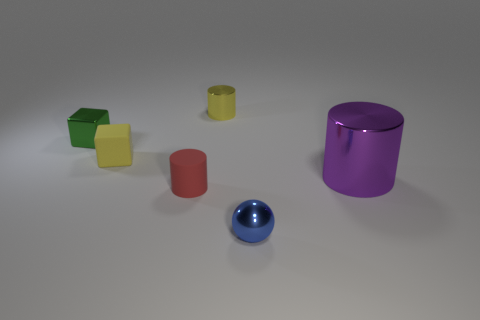What number of other things are there of the same material as the yellow cylinder
Offer a very short reply. 3. What size is the metal cylinder that is in front of the small green metal object?
Offer a very short reply. Large. There is a tiny matte thing in front of the large purple shiny thing; what number of tiny blue metallic spheres are behind it?
Offer a terse response. 0. There is a matte thing that is in front of the purple object; does it have the same shape as the shiny thing that is behind the tiny green metal object?
Your response must be concise. Yes. What number of cylinders are to the left of the large metallic thing and in front of the small green metal thing?
Offer a very short reply. 1. Is there a tiny cylinder that has the same color as the rubber block?
Make the answer very short. Yes. There is a blue object that is the same size as the yellow matte cube; what is its shape?
Your answer should be very brief. Sphere. There is a tiny metal cylinder; are there any purple metal cylinders on the right side of it?
Offer a very short reply. Yes. Is the thing right of the small shiny ball made of the same material as the tiny cylinder that is in front of the tiny yellow matte thing?
Provide a succinct answer. No. What number of purple metal things are the same size as the purple cylinder?
Make the answer very short. 0. 